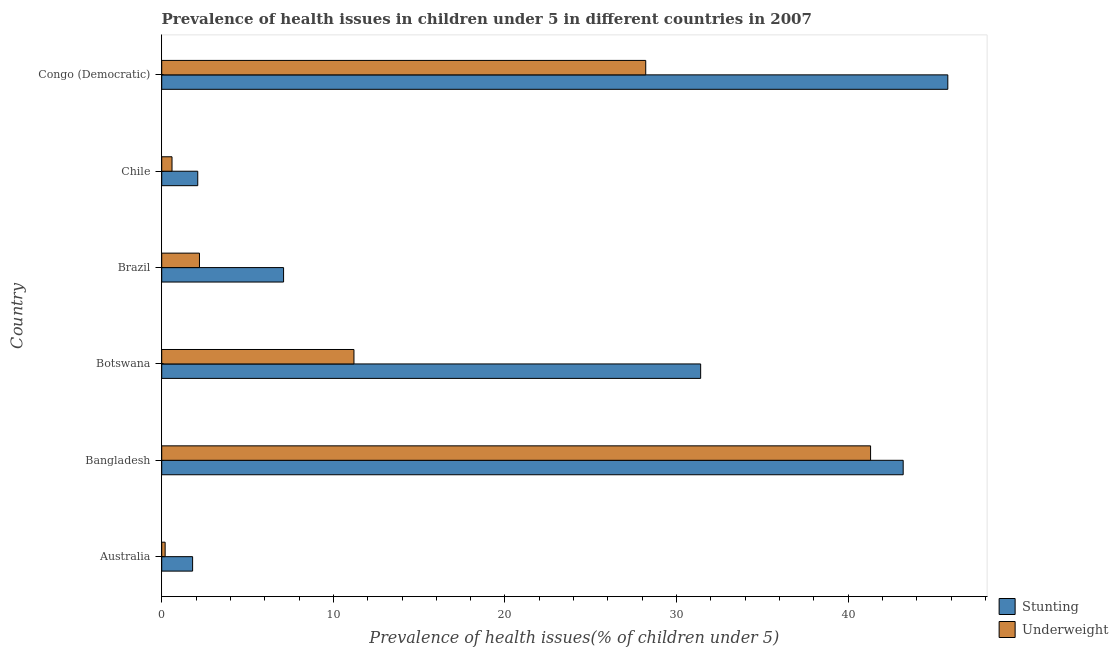How many different coloured bars are there?
Your answer should be compact. 2. Are the number of bars per tick equal to the number of legend labels?
Provide a short and direct response. Yes. How many bars are there on the 3rd tick from the top?
Make the answer very short. 2. How many bars are there on the 6th tick from the bottom?
Your response must be concise. 2. What is the label of the 1st group of bars from the top?
Ensure brevity in your answer.  Congo (Democratic). In how many cases, is the number of bars for a given country not equal to the number of legend labels?
Ensure brevity in your answer.  0. What is the percentage of stunted children in Bangladesh?
Your response must be concise. 43.2. Across all countries, what is the maximum percentage of underweight children?
Give a very brief answer. 41.3. Across all countries, what is the minimum percentage of stunted children?
Your response must be concise. 1.8. In which country was the percentage of underweight children maximum?
Make the answer very short. Bangladesh. What is the total percentage of underweight children in the graph?
Give a very brief answer. 83.7. What is the difference between the percentage of underweight children in Bangladesh and that in Chile?
Make the answer very short. 40.7. What is the difference between the percentage of stunted children in Congo (Democratic) and the percentage of underweight children in Brazil?
Offer a very short reply. 43.6. What is the average percentage of underweight children per country?
Keep it short and to the point. 13.95. What is the difference between the percentage of stunted children and percentage of underweight children in Bangladesh?
Offer a very short reply. 1.9. What is the ratio of the percentage of underweight children in Australia to that in Bangladesh?
Your response must be concise. 0.01. What is the difference between the highest and the second highest percentage of stunted children?
Your answer should be compact. 2.6. What is the difference between the highest and the lowest percentage of underweight children?
Provide a succinct answer. 41.1. Is the sum of the percentage of underweight children in Botswana and Congo (Democratic) greater than the maximum percentage of stunted children across all countries?
Keep it short and to the point. No. What does the 1st bar from the top in Brazil represents?
Provide a succinct answer. Underweight. What does the 2nd bar from the bottom in Australia represents?
Your answer should be compact. Underweight. How many countries are there in the graph?
Your answer should be very brief. 6. Does the graph contain any zero values?
Give a very brief answer. No. Does the graph contain grids?
Your response must be concise. No. How many legend labels are there?
Keep it short and to the point. 2. What is the title of the graph?
Offer a very short reply. Prevalence of health issues in children under 5 in different countries in 2007. Does "IMF nonconcessional" appear as one of the legend labels in the graph?
Ensure brevity in your answer.  No. What is the label or title of the X-axis?
Your answer should be very brief. Prevalence of health issues(% of children under 5). What is the Prevalence of health issues(% of children under 5) of Stunting in Australia?
Your answer should be compact. 1.8. What is the Prevalence of health issues(% of children under 5) of Underweight in Australia?
Make the answer very short. 0.2. What is the Prevalence of health issues(% of children under 5) of Stunting in Bangladesh?
Your answer should be compact. 43.2. What is the Prevalence of health issues(% of children under 5) in Underweight in Bangladesh?
Your response must be concise. 41.3. What is the Prevalence of health issues(% of children under 5) of Stunting in Botswana?
Ensure brevity in your answer.  31.4. What is the Prevalence of health issues(% of children under 5) in Underweight in Botswana?
Give a very brief answer. 11.2. What is the Prevalence of health issues(% of children under 5) in Stunting in Brazil?
Make the answer very short. 7.1. What is the Prevalence of health issues(% of children under 5) in Underweight in Brazil?
Provide a short and direct response. 2.2. What is the Prevalence of health issues(% of children under 5) of Stunting in Chile?
Your answer should be compact. 2.1. What is the Prevalence of health issues(% of children under 5) in Underweight in Chile?
Your answer should be compact. 0.6. What is the Prevalence of health issues(% of children under 5) of Stunting in Congo (Democratic)?
Ensure brevity in your answer.  45.8. What is the Prevalence of health issues(% of children under 5) in Underweight in Congo (Democratic)?
Make the answer very short. 28.2. Across all countries, what is the maximum Prevalence of health issues(% of children under 5) of Stunting?
Provide a short and direct response. 45.8. Across all countries, what is the maximum Prevalence of health issues(% of children under 5) in Underweight?
Your response must be concise. 41.3. Across all countries, what is the minimum Prevalence of health issues(% of children under 5) in Stunting?
Your response must be concise. 1.8. Across all countries, what is the minimum Prevalence of health issues(% of children under 5) in Underweight?
Your answer should be very brief. 0.2. What is the total Prevalence of health issues(% of children under 5) in Stunting in the graph?
Your response must be concise. 131.4. What is the total Prevalence of health issues(% of children under 5) in Underweight in the graph?
Provide a short and direct response. 83.7. What is the difference between the Prevalence of health issues(% of children under 5) of Stunting in Australia and that in Bangladesh?
Ensure brevity in your answer.  -41.4. What is the difference between the Prevalence of health issues(% of children under 5) in Underweight in Australia and that in Bangladesh?
Ensure brevity in your answer.  -41.1. What is the difference between the Prevalence of health issues(% of children under 5) in Stunting in Australia and that in Botswana?
Provide a short and direct response. -29.6. What is the difference between the Prevalence of health issues(% of children under 5) in Stunting in Australia and that in Brazil?
Offer a terse response. -5.3. What is the difference between the Prevalence of health issues(% of children under 5) of Underweight in Australia and that in Chile?
Give a very brief answer. -0.4. What is the difference between the Prevalence of health issues(% of children under 5) in Stunting in Australia and that in Congo (Democratic)?
Ensure brevity in your answer.  -44. What is the difference between the Prevalence of health issues(% of children under 5) of Underweight in Australia and that in Congo (Democratic)?
Provide a short and direct response. -28. What is the difference between the Prevalence of health issues(% of children under 5) of Underweight in Bangladesh and that in Botswana?
Keep it short and to the point. 30.1. What is the difference between the Prevalence of health issues(% of children under 5) of Stunting in Bangladesh and that in Brazil?
Your response must be concise. 36.1. What is the difference between the Prevalence of health issues(% of children under 5) in Underweight in Bangladesh and that in Brazil?
Make the answer very short. 39.1. What is the difference between the Prevalence of health issues(% of children under 5) of Stunting in Bangladesh and that in Chile?
Your response must be concise. 41.1. What is the difference between the Prevalence of health issues(% of children under 5) in Underweight in Bangladesh and that in Chile?
Keep it short and to the point. 40.7. What is the difference between the Prevalence of health issues(% of children under 5) in Underweight in Bangladesh and that in Congo (Democratic)?
Provide a short and direct response. 13.1. What is the difference between the Prevalence of health issues(% of children under 5) of Stunting in Botswana and that in Brazil?
Provide a short and direct response. 24.3. What is the difference between the Prevalence of health issues(% of children under 5) in Underweight in Botswana and that in Brazil?
Ensure brevity in your answer.  9. What is the difference between the Prevalence of health issues(% of children under 5) in Stunting in Botswana and that in Chile?
Make the answer very short. 29.3. What is the difference between the Prevalence of health issues(% of children under 5) of Stunting in Botswana and that in Congo (Democratic)?
Make the answer very short. -14.4. What is the difference between the Prevalence of health issues(% of children under 5) in Stunting in Brazil and that in Chile?
Keep it short and to the point. 5. What is the difference between the Prevalence of health issues(% of children under 5) of Stunting in Brazil and that in Congo (Democratic)?
Provide a short and direct response. -38.7. What is the difference between the Prevalence of health issues(% of children under 5) of Underweight in Brazil and that in Congo (Democratic)?
Your answer should be very brief. -26. What is the difference between the Prevalence of health issues(% of children under 5) of Stunting in Chile and that in Congo (Democratic)?
Offer a terse response. -43.7. What is the difference between the Prevalence of health issues(% of children under 5) in Underweight in Chile and that in Congo (Democratic)?
Offer a very short reply. -27.6. What is the difference between the Prevalence of health issues(% of children under 5) in Stunting in Australia and the Prevalence of health issues(% of children under 5) in Underweight in Bangladesh?
Keep it short and to the point. -39.5. What is the difference between the Prevalence of health issues(% of children under 5) in Stunting in Australia and the Prevalence of health issues(% of children under 5) in Underweight in Congo (Democratic)?
Keep it short and to the point. -26.4. What is the difference between the Prevalence of health issues(% of children under 5) in Stunting in Bangladesh and the Prevalence of health issues(% of children under 5) in Underweight in Brazil?
Provide a succinct answer. 41. What is the difference between the Prevalence of health issues(% of children under 5) in Stunting in Bangladesh and the Prevalence of health issues(% of children under 5) in Underweight in Chile?
Make the answer very short. 42.6. What is the difference between the Prevalence of health issues(% of children under 5) in Stunting in Botswana and the Prevalence of health issues(% of children under 5) in Underweight in Brazil?
Offer a terse response. 29.2. What is the difference between the Prevalence of health issues(% of children under 5) in Stunting in Botswana and the Prevalence of health issues(% of children under 5) in Underweight in Chile?
Offer a very short reply. 30.8. What is the difference between the Prevalence of health issues(% of children under 5) of Stunting in Botswana and the Prevalence of health issues(% of children under 5) of Underweight in Congo (Democratic)?
Give a very brief answer. 3.2. What is the difference between the Prevalence of health issues(% of children under 5) of Stunting in Brazil and the Prevalence of health issues(% of children under 5) of Underweight in Congo (Democratic)?
Provide a succinct answer. -21.1. What is the difference between the Prevalence of health issues(% of children under 5) of Stunting in Chile and the Prevalence of health issues(% of children under 5) of Underweight in Congo (Democratic)?
Offer a terse response. -26.1. What is the average Prevalence of health issues(% of children under 5) in Stunting per country?
Your response must be concise. 21.9. What is the average Prevalence of health issues(% of children under 5) of Underweight per country?
Your response must be concise. 13.95. What is the difference between the Prevalence of health issues(% of children under 5) of Stunting and Prevalence of health issues(% of children under 5) of Underweight in Australia?
Your answer should be compact. 1.6. What is the difference between the Prevalence of health issues(% of children under 5) in Stunting and Prevalence of health issues(% of children under 5) in Underweight in Botswana?
Offer a very short reply. 20.2. What is the difference between the Prevalence of health issues(% of children under 5) in Stunting and Prevalence of health issues(% of children under 5) in Underweight in Chile?
Make the answer very short. 1.5. What is the ratio of the Prevalence of health issues(% of children under 5) of Stunting in Australia to that in Bangladesh?
Offer a terse response. 0.04. What is the ratio of the Prevalence of health issues(% of children under 5) in Underweight in Australia to that in Bangladesh?
Offer a very short reply. 0. What is the ratio of the Prevalence of health issues(% of children under 5) in Stunting in Australia to that in Botswana?
Offer a terse response. 0.06. What is the ratio of the Prevalence of health issues(% of children under 5) in Underweight in Australia to that in Botswana?
Your answer should be compact. 0.02. What is the ratio of the Prevalence of health issues(% of children under 5) in Stunting in Australia to that in Brazil?
Make the answer very short. 0.25. What is the ratio of the Prevalence of health issues(% of children under 5) in Underweight in Australia to that in Brazil?
Your response must be concise. 0.09. What is the ratio of the Prevalence of health issues(% of children under 5) of Stunting in Australia to that in Congo (Democratic)?
Offer a very short reply. 0.04. What is the ratio of the Prevalence of health issues(% of children under 5) in Underweight in Australia to that in Congo (Democratic)?
Your response must be concise. 0.01. What is the ratio of the Prevalence of health issues(% of children under 5) of Stunting in Bangladesh to that in Botswana?
Your answer should be compact. 1.38. What is the ratio of the Prevalence of health issues(% of children under 5) of Underweight in Bangladesh to that in Botswana?
Offer a very short reply. 3.69. What is the ratio of the Prevalence of health issues(% of children under 5) in Stunting in Bangladesh to that in Brazil?
Provide a short and direct response. 6.08. What is the ratio of the Prevalence of health issues(% of children under 5) in Underweight in Bangladesh to that in Brazil?
Your response must be concise. 18.77. What is the ratio of the Prevalence of health issues(% of children under 5) of Stunting in Bangladesh to that in Chile?
Keep it short and to the point. 20.57. What is the ratio of the Prevalence of health issues(% of children under 5) of Underweight in Bangladesh to that in Chile?
Provide a succinct answer. 68.83. What is the ratio of the Prevalence of health issues(% of children under 5) in Stunting in Bangladesh to that in Congo (Democratic)?
Offer a very short reply. 0.94. What is the ratio of the Prevalence of health issues(% of children under 5) of Underweight in Bangladesh to that in Congo (Democratic)?
Your response must be concise. 1.46. What is the ratio of the Prevalence of health issues(% of children under 5) of Stunting in Botswana to that in Brazil?
Offer a very short reply. 4.42. What is the ratio of the Prevalence of health issues(% of children under 5) of Underweight in Botswana to that in Brazil?
Provide a short and direct response. 5.09. What is the ratio of the Prevalence of health issues(% of children under 5) in Stunting in Botswana to that in Chile?
Provide a succinct answer. 14.95. What is the ratio of the Prevalence of health issues(% of children under 5) in Underweight in Botswana to that in Chile?
Ensure brevity in your answer.  18.67. What is the ratio of the Prevalence of health issues(% of children under 5) of Stunting in Botswana to that in Congo (Democratic)?
Ensure brevity in your answer.  0.69. What is the ratio of the Prevalence of health issues(% of children under 5) in Underweight in Botswana to that in Congo (Democratic)?
Provide a succinct answer. 0.4. What is the ratio of the Prevalence of health issues(% of children under 5) of Stunting in Brazil to that in Chile?
Keep it short and to the point. 3.38. What is the ratio of the Prevalence of health issues(% of children under 5) in Underweight in Brazil to that in Chile?
Offer a very short reply. 3.67. What is the ratio of the Prevalence of health issues(% of children under 5) of Stunting in Brazil to that in Congo (Democratic)?
Your response must be concise. 0.15. What is the ratio of the Prevalence of health issues(% of children under 5) in Underweight in Brazil to that in Congo (Democratic)?
Offer a very short reply. 0.08. What is the ratio of the Prevalence of health issues(% of children under 5) in Stunting in Chile to that in Congo (Democratic)?
Provide a succinct answer. 0.05. What is the ratio of the Prevalence of health issues(% of children under 5) of Underweight in Chile to that in Congo (Democratic)?
Your answer should be compact. 0.02. What is the difference between the highest and the second highest Prevalence of health issues(% of children under 5) in Stunting?
Give a very brief answer. 2.6. What is the difference between the highest and the second highest Prevalence of health issues(% of children under 5) in Underweight?
Your answer should be compact. 13.1. What is the difference between the highest and the lowest Prevalence of health issues(% of children under 5) in Stunting?
Your answer should be very brief. 44. What is the difference between the highest and the lowest Prevalence of health issues(% of children under 5) of Underweight?
Offer a very short reply. 41.1. 